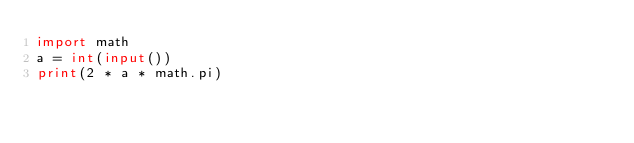<code> <loc_0><loc_0><loc_500><loc_500><_Python_>import math
a = int(input())
print(2 * a * math.pi)</code> 